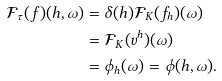<formula> <loc_0><loc_0><loc_500><loc_500>\mathcal { F } _ { \tau } ( f ) ( h , \omega ) & = \delta ( h ) \mathcal { F } _ { K } ( f _ { h } ) ( \omega ) \\ & = \mathcal { F } _ { K } ( v ^ { h } ) ( \omega ) \\ & = \phi _ { h } ( \omega ) = \phi ( h , \omega ) .</formula> 